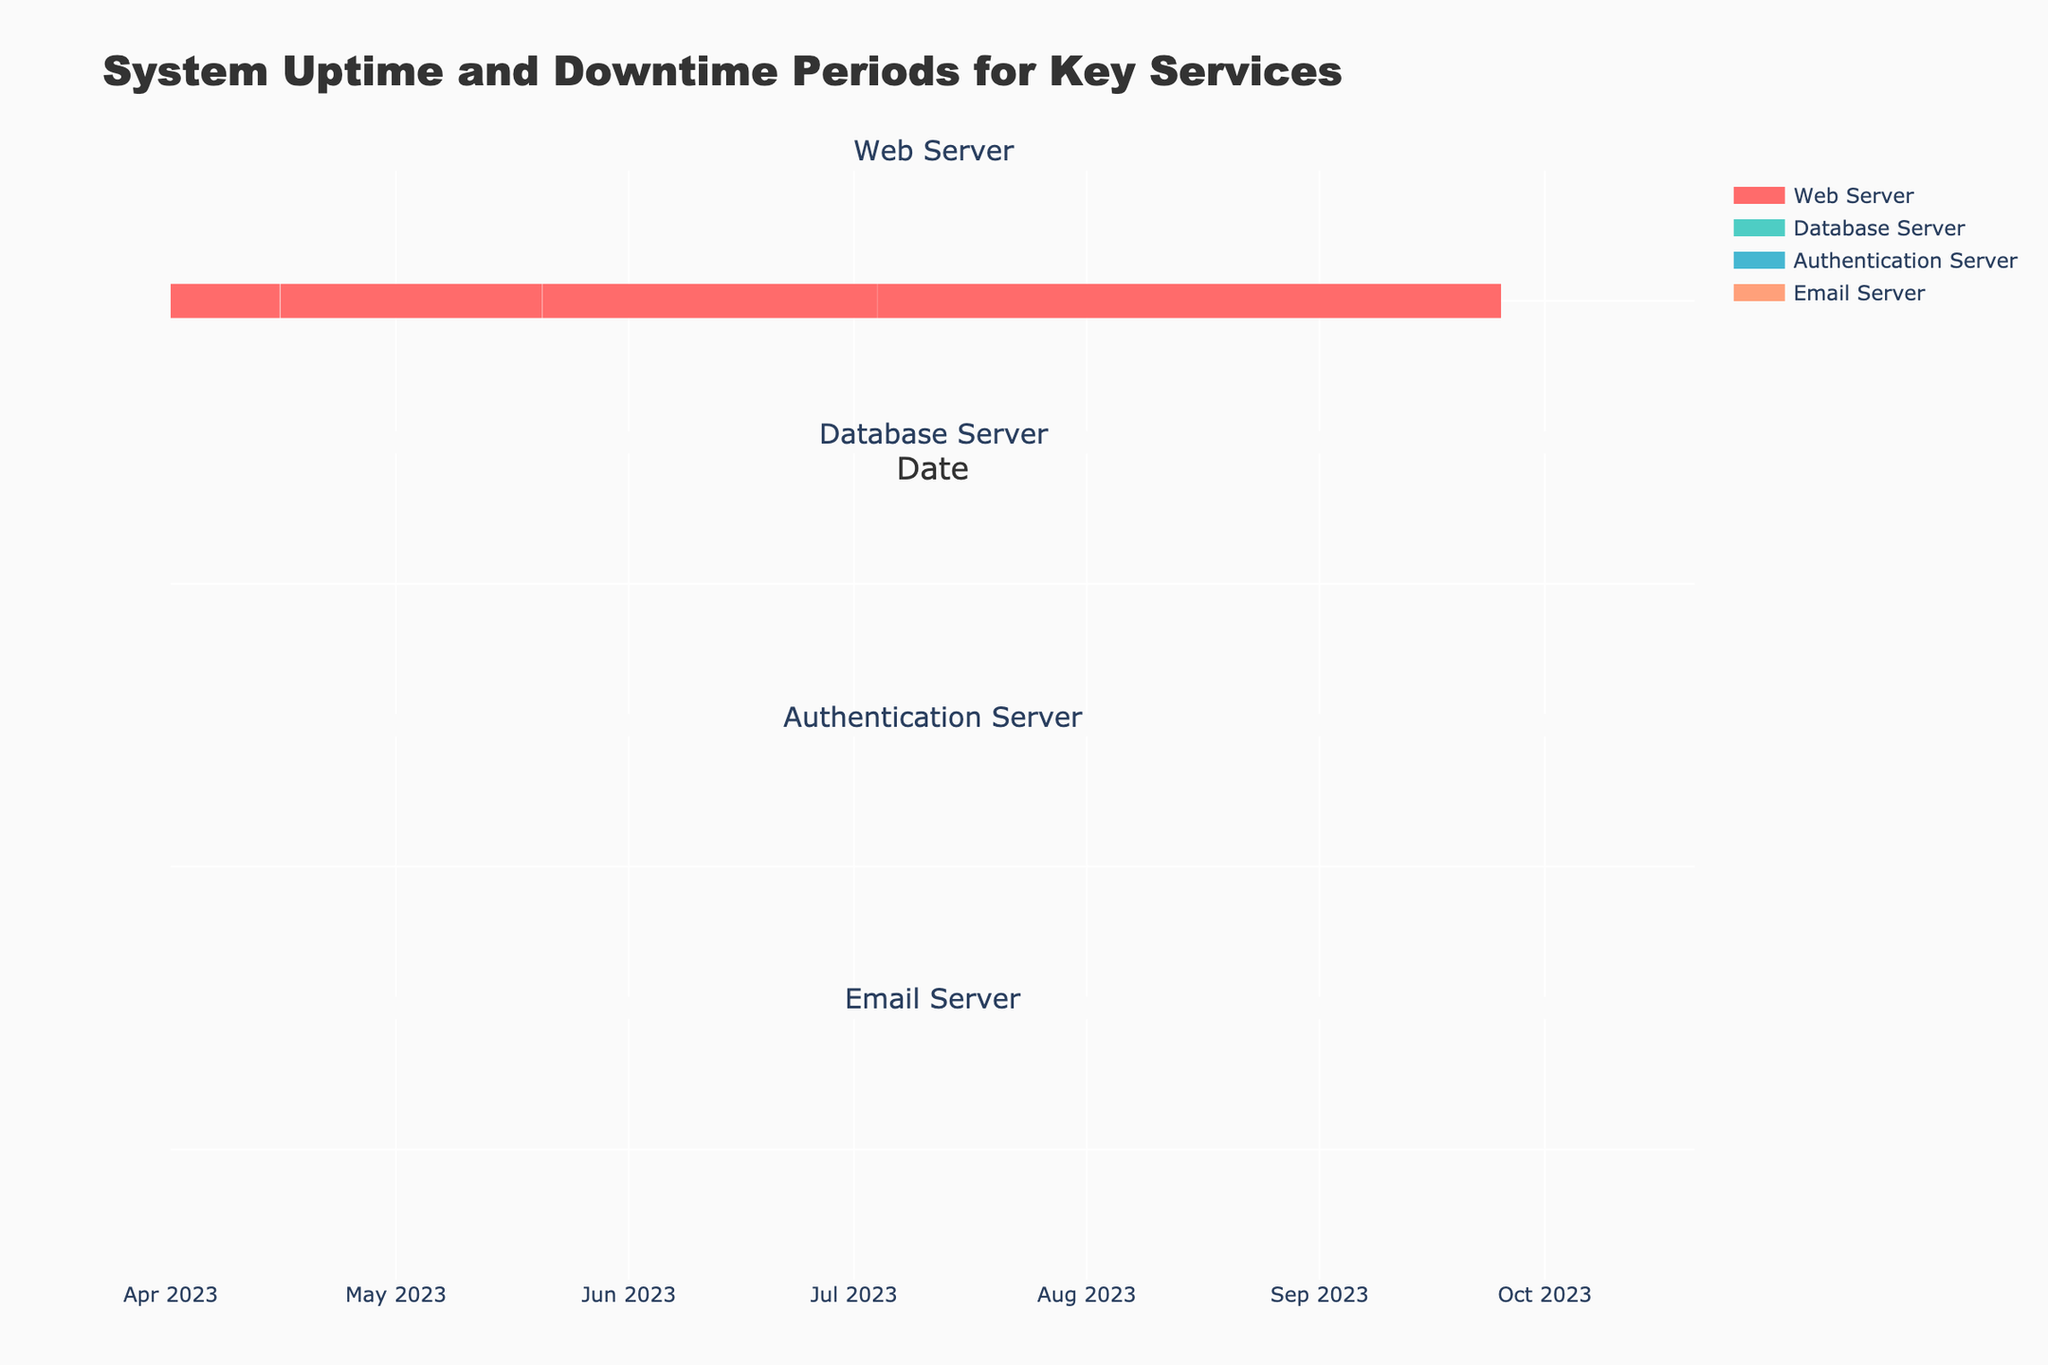How many downtime periods did the Web Server experience over the past six months? By observing the figure, we can identify downtime periods by the segments in grey color within the Web Server's dedicated subplot. Count the grey segments for the Web Server.
Answer: 5 What was the longest downtime period for any service in the past six months? By examining the length of each grey segment across all services, it appears that the longest segment represents the downtime for the Database Server on 2023-05-05, lasting from 03:00 to 06:25. Compare this duration with others.
Answer: Database Server (3 hours and 25 minutes) Which service experienced the most frequent downtimes? By counting the number of grey segments for each of the services, the Web Server has the most, with 5 downtime periods over the given time frame.
Answer: Web Server Were there any months where the Authentication Server did not experience any downtime? Check each month's subplot for the Authentication Server. In April and July, there are no grey segments observed for the Authentication Server.
Answer: April, July On which date did the Email Server experience its first downtime? Look at the first grey segment in the Email Server's subplot. The Email Server first experienced downtime on 2023-06-25.
Answer: 2023-06-25 How does the Email Server's downtime frequency compare to the Database Server's? Count and compare the number of downtime periods for both the Email Server and the Database Server. Both services experienced 2 downtime periods over the past six months.
Answer: Equal Which service had downtime periods of less than an hour? Examine the lengths of grey segments for each service. The Web Server had three instances (2023-05-20, 2023-07-04, and 2023-09-25) where the downtime lasted less than an hour.
Answer: Web Server How many total downtime segments are there across all services? Count every downtime segment in the figure. Adding all grey segments gives a total of 10.
Answer: 10 When did the Authentication Server have its downtime in June, and for how long? Identify the grey segment for the Authentication Server in June's subplot. There was downtime on 2023-06-12 from 20:00 to 22:30, lasting 2.5 hours.
Answer: 2023-06-12 (2.5 hours) Which service had the longest uptime without interruption? Check the intervals between grey segments in each subplot. The Web Server, from the initial uptime on 2023-04-01 until its first downtime on 2023-04-15, had the longest continuous uptime without interruption (14 days).
Answer: Web Server (14 days) 